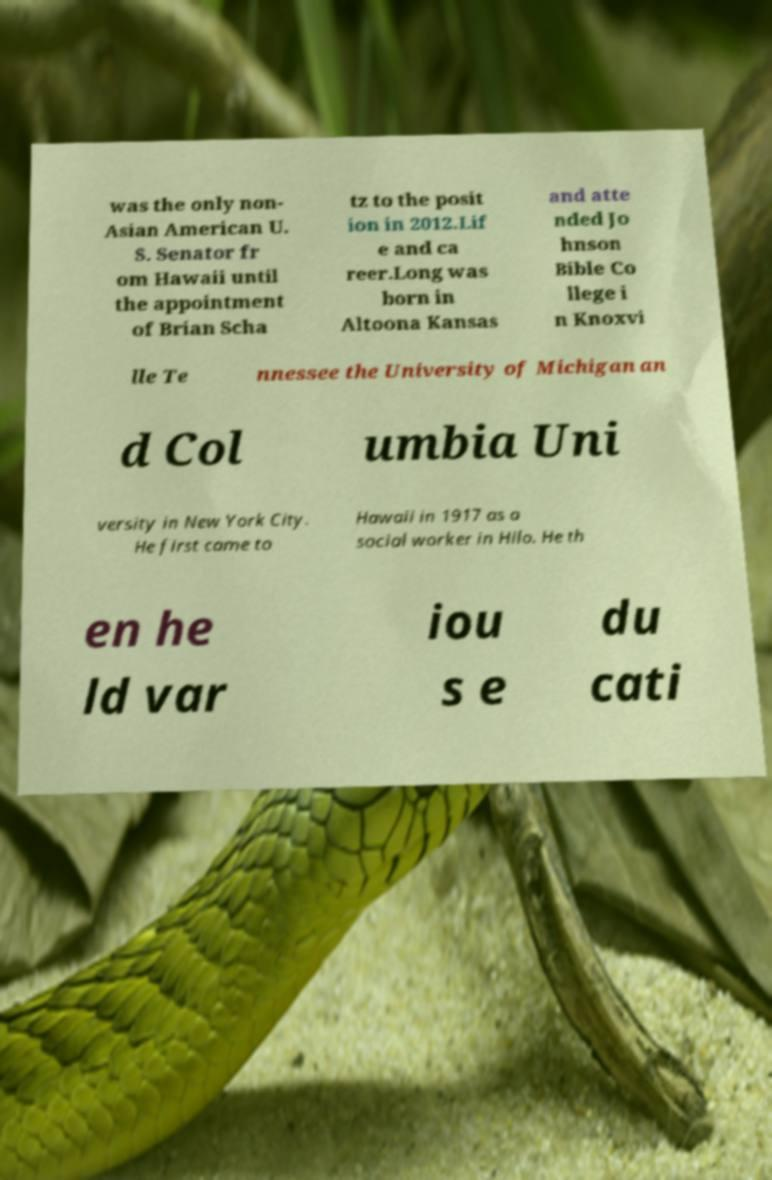Can you read and provide the text displayed in the image?This photo seems to have some interesting text. Can you extract and type it out for me? was the only non- Asian American U. S. Senator fr om Hawaii until the appointment of Brian Scha tz to the posit ion in 2012.Lif e and ca reer.Long was born in Altoona Kansas and atte nded Jo hnson Bible Co llege i n Knoxvi lle Te nnessee the University of Michigan an d Col umbia Uni versity in New York City. He first came to Hawaii in 1917 as a social worker in Hilo. He th en he ld var iou s e du cati 